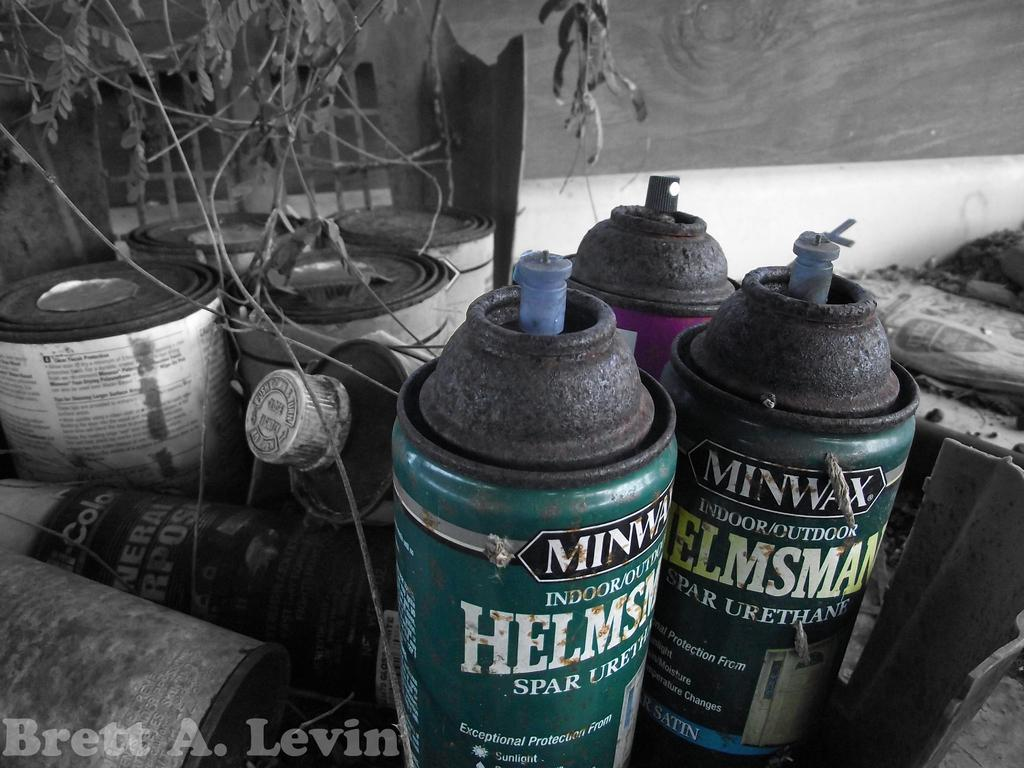<image>
Offer a succinct explanation of the picture presented. A few cans of Minwax spray sit near each other. 